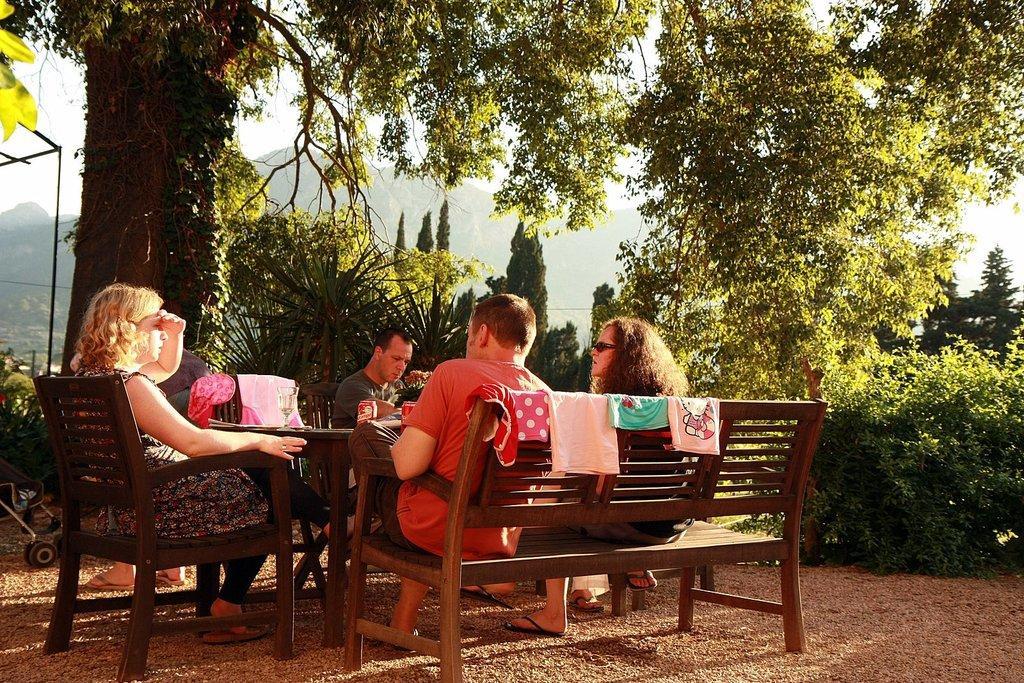Could you give a brief overview of what you see in this image? This picture shows there are some people sitting in the chair and a bench in front of a table, on which some tissues and tins were placed. There are some plants, trees here. In the background there is a hill and a sky here. 